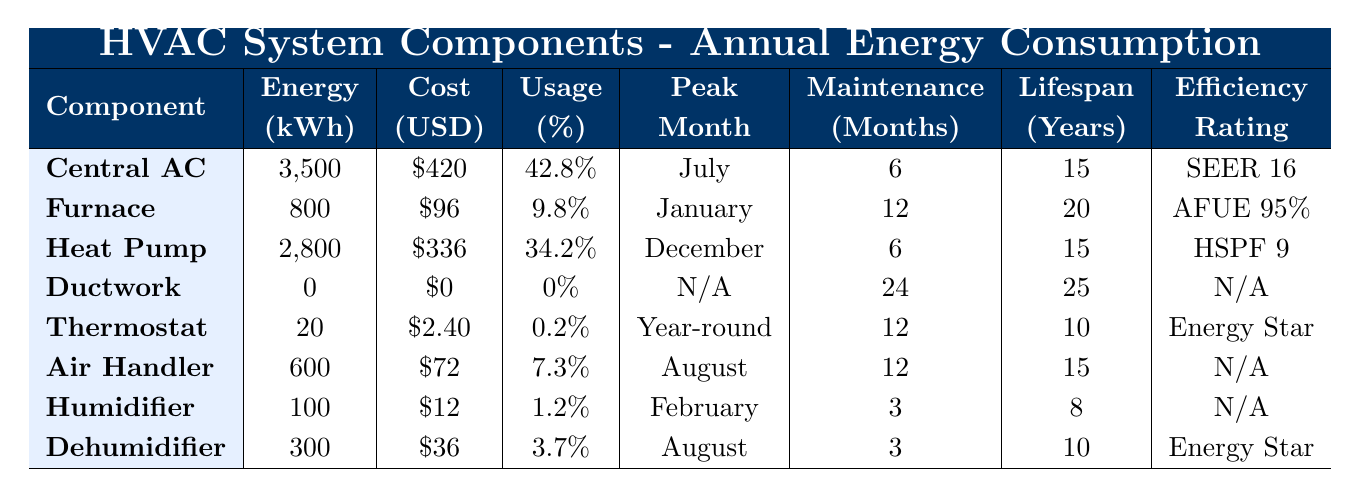What HVAC component consumes the most energy annually? The table shows that the Central Air Conditioner has an annual energy consumption of 3500 kWh, which is the highest among all components listed.
Answer: Central Air Conditioner What is the annual energy cost of the Furnace? The table indicates that the annual energy cost for the Furnace is $96.
Answer: $96 Which components have a maintenance frequency of 3 months? Looking at the maintenance frequency column, both the Humidifier and Dehumidifier are listed with a maintenance frequency of 3 months.
Answer: Humidifier and Dehumidifier What is the combined annual energy consumption of all components? By adding up all the annual energy consumption values: 3500 + 800 + 2800 + 0 + 20 + 600 + 100 + 300 = 8300 kWh.
Answer: 8300 kWh Which HVAC component has the longest lifespan? The lifespan of the Ductwork is 25 years, which is listed as the longest lifespan compared to the other components.
Answer: Ductwork Is the Heat Pump more energy-efficient than the Central Air Conditioner based on the efficiency ratings? The Heat Pump has an efficiency rating of HSPF 9, while the Central Air Conditioner has SEER 16. Higher SEER ratings indicate more efficient cooling, so the Central AC is more energy-efficient.
Answer: No What percentage of total HVAC energy use does the Thermostat account for? The table shows that the Thermostat accounts for 0.2% of the total HVAC energy use.
Answer: 0.2% Considering all components except Ductwork, what is the average annual energy consumption? Summing the energy consumption for all components except Ductwork gives: 3500 + 800 + 2800 + 20 + 600 + 100 + 300 = 6000 kWh. There are 7 components, so the average is 6000 / 7 = approximately 857.14 kWh.
Answer: Approximately 857.14 kWh Which component has a energy cost of $36? The Dehumidifier is listed in the table with an annual energy cost of $36.
Answer: Dehumidifier Is the average lifespan of the Humidifier greater than the average lifespan of the Thermostat? The Humidifier has an average lifespan of 8 years, while the Thermostat has an average lifespan of 10 years. Since 10 years is greater than 8 years, the statement is false.
Answer: No Which HVAC component has an annual energy consumption of 0 kWh? The Ductwork is listed as having an annual energy consumption of 0 kWh in the table.
Answer: Ductwork 